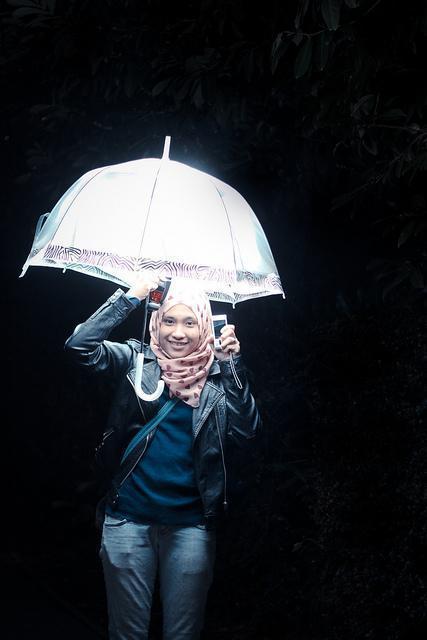How many buses are behind a street sign?
Give a very brief answer. 0. 